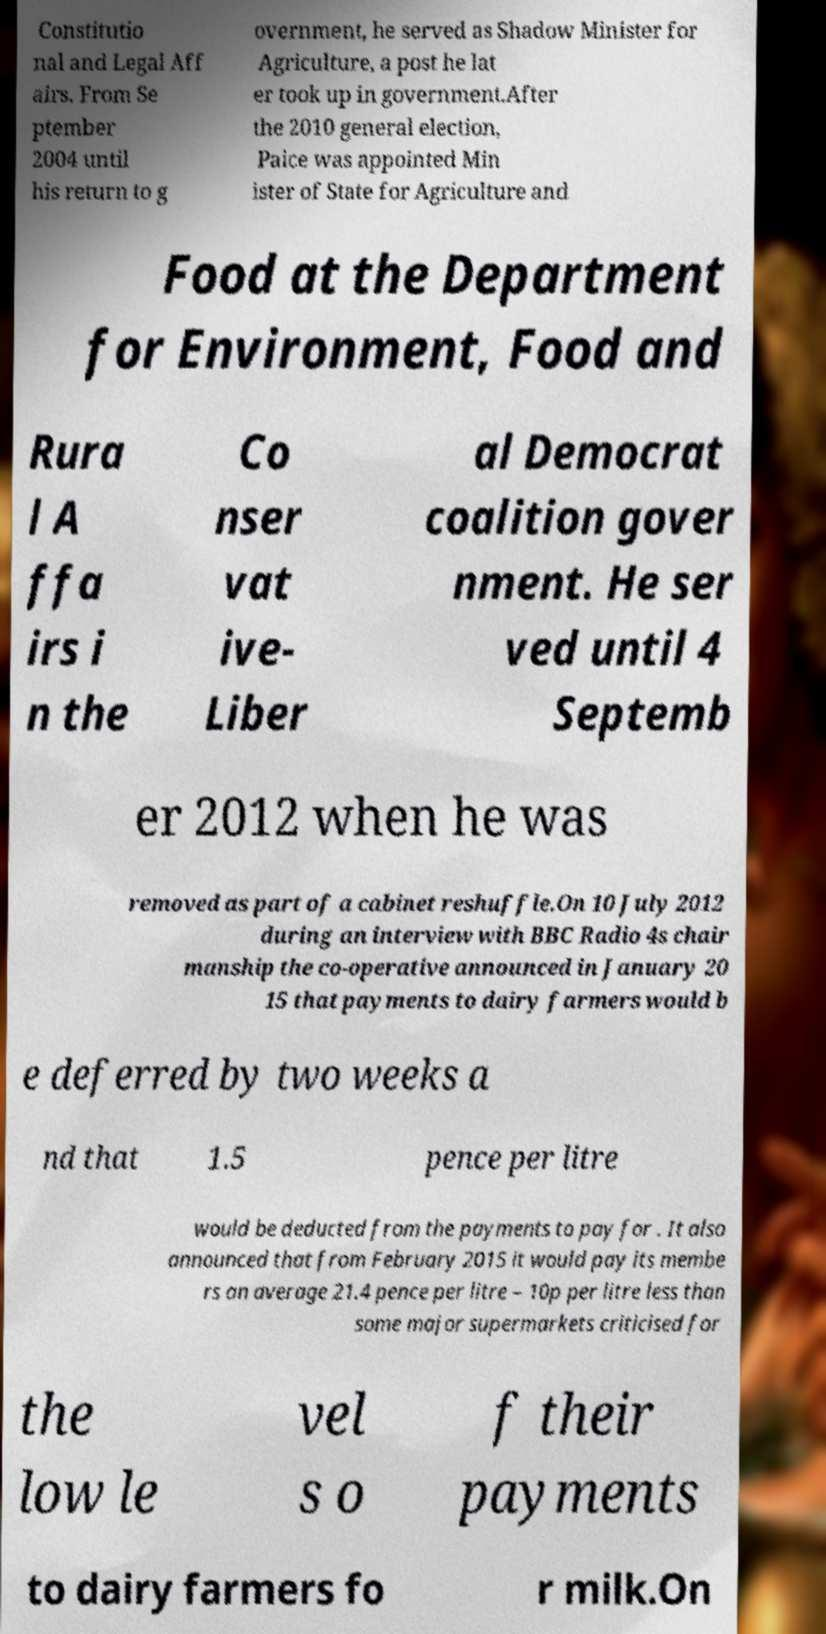There's text embedded in this image that I need extracted. Can you transcribe it verbatim? Constitutio nal and Legal Aff airs. From Se ptember 2004 until his return to g overnment, he served as Shadow Minister for Agriculture, a post he lat er took up in government.After the 2010 general election, Paice was appointed Min ister of State for Agriculture and Food at the Department for Environment, Food and Rura l A ffa irs i n the Co nser vat ive- Liber al Democrat coalition gover nment. He ser ved until 4 Septemb er 2012 when he was removed as part of a cabinet reshuffle.On 10 July 2012 during an interview with BBC Radio 4s chair manship the co-operative announced in January 20 15 that payments to dairy farmers would b e deferred by two weeks a nd that 1.5 pence per litre would be deducted from the payments to pay for . It also announced that from February 2015 it would pay its membe rs an average 21.4 pence per litre – 10p per litre less than some major supermarkets criticised for the low le vel s o f their payments to dairy farmers fo r milk.On 